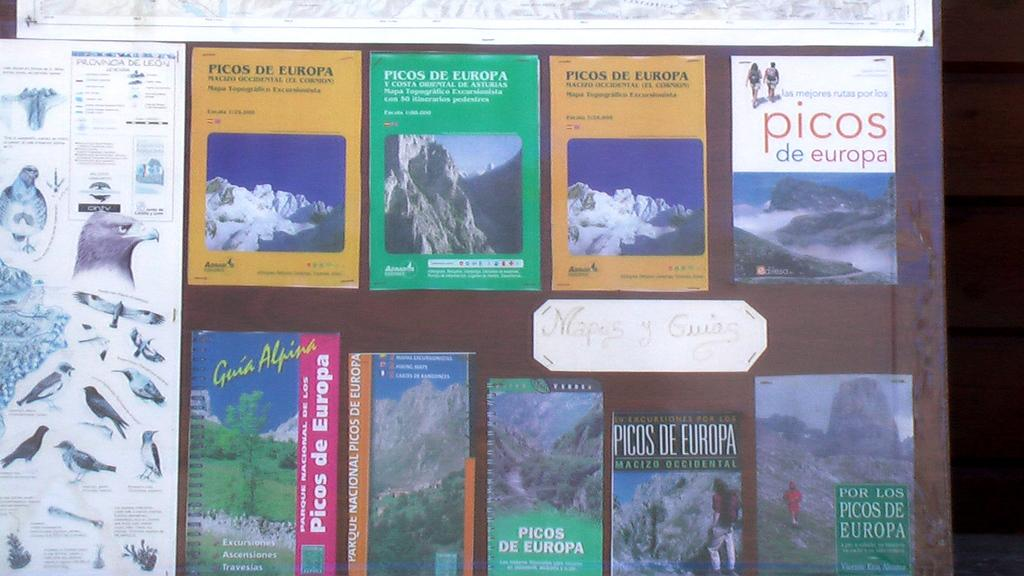Provide a one-sentence caption for the provided image. Different pamphlets and maps for Picos de Europe are arranged by a poster of birds. 